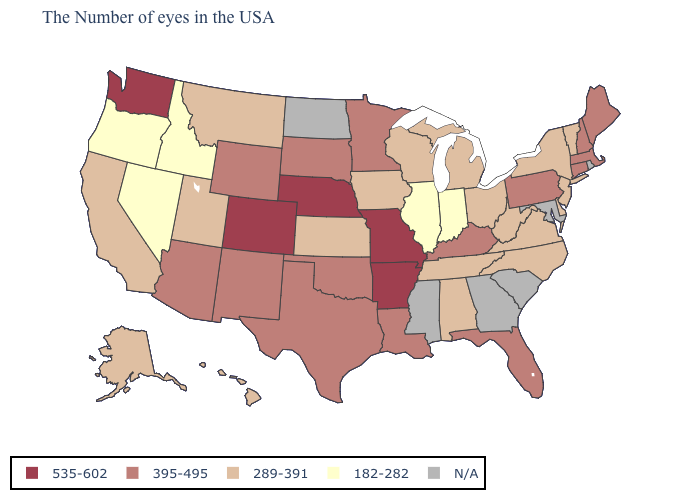Among the states that border Utah , does New Mexico have the lowest value?
Concise answer only. No. Name the states that have a value in the range 182-282?
Keep it brief. Indiana, Illinois, Idaho, Nevada, Oregon. What is the value of Maine?
Keep it brief. 395-495. Does the first symbol in the legend represent the smallest category?
Keep it brief. No. Which states have the highest value in the USA?
Concise answer only. Missouri, Arkansas, Nebraska, Colorado, Washington. Among the states that border Illinois , which have the highest value?
Keep it brief. Missouri. Name the states that have a value in the range 182-282?
Short answer required. Indiana, Illinois, Idaho, Nevada, Oregon. Name the states that have a value in the range 182-282?
Quick response, please. Indiana, Illinois, Idaho, Nevada, Oregon. Does the map have missing data?
Answer briefly. Yes. Among the states that border Arizona , which have the lowest value?
Write a very short answer. Nevada. How many symbols are there in the legend?
Quick response, please. 5. What is the lowest value in the MidWest?
Write a very short answer. 182-282. What is the value of New York?
Concise answer only. 289-391. What is the value of North Dakota?
Keep it brief. N/A. Name the states that have a value in the range 395-495?
Quick response, please. Maine, Massachusetts, New Hampshire, Connecticut, Pennsylvania, Florida, Kentucky, Louisiana, Minnesota, Oklahoma, Texas, South Dakota, Wyoming, New Mexico, Arizona. 